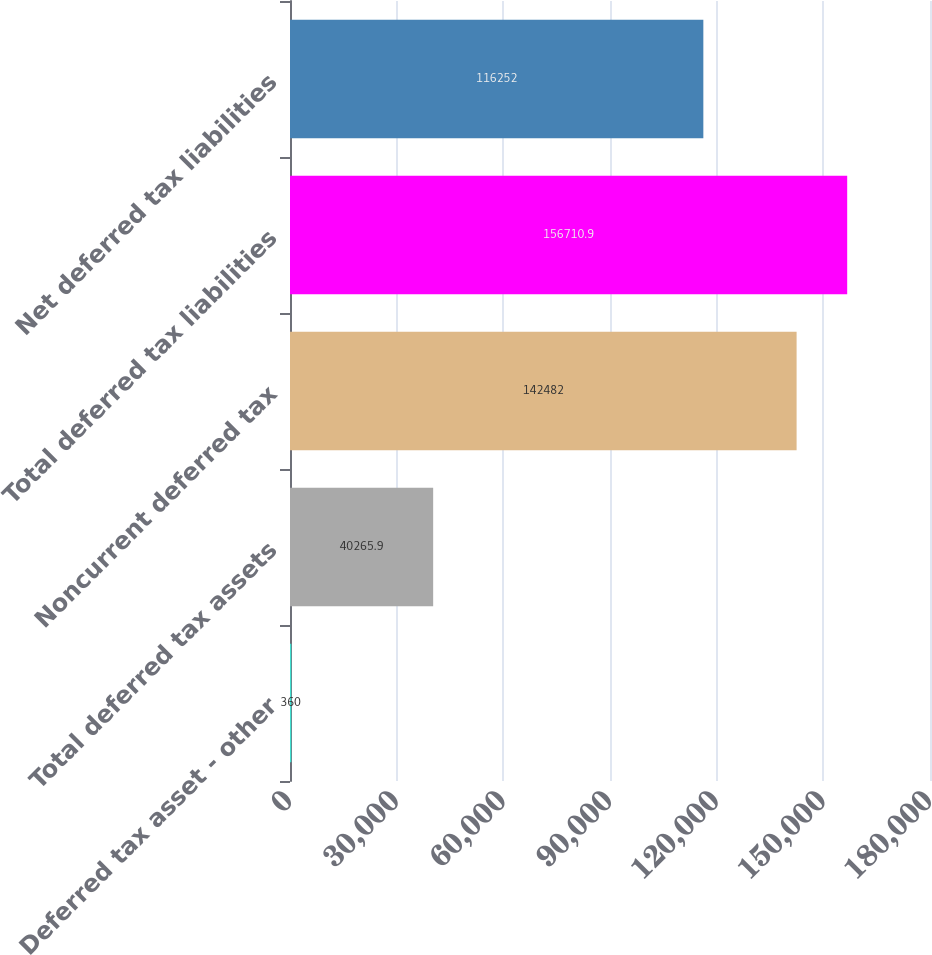Convert chart to OTSL. <chart><loc_0><loc_0><loc_500><loc_500><bar_chart><fcel>Deferred tax asset - other<fcel>Total deferred tax assets<fcel>Noncurrent deferred tax<fcel>Total deferred tax liabilities<fcel>Net deferred tax liabilities<nl><fcel>360<fcel>40265.9<fcel>142482<fcel>156711<fcel>116252<nl></chart> 